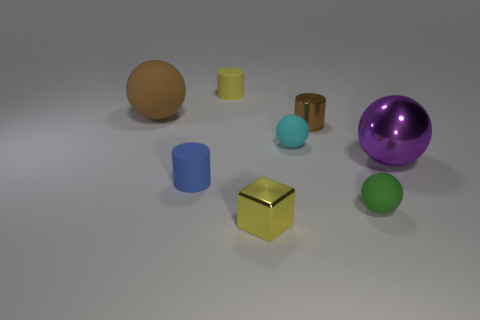Are there any matte things of the same color as the tiny metal cube?
Provide a short and direct response. Yes. There is a object that is the same color as the tiny shiny cylinder; what size is it?
Make the answer very short. Large. There is another object that is the same size as the purple shiny object; what is its color?
Ensure brevity in your answer.  Brown. There is a brown matte thing; does it have the same shape as the big thing to the right of the small cyan thing?
Ensure brevity in your answer.  Yes. What number of things are small things that are behind the green matte sphere or objects that are right of the brown matte sphere?
Your response must be concise. 7. There is a matte object that is the same color as the metal cube; what shape is it?
Offer a terse response. Cylinder. There is a large object on the left side of the tiny yellow metallic cube; what is its shape?
Offer a very short reply. Sphere. There is a shiny thing that is right of the brown shiny thing; does it have the same shape as the yellow shiny thing?
Give a very brief answer. No. What number of things are matte things right of the tiny cube or big purple balls?
Offer a terse response. 3. What is the color of the other tiny object that is the same shape as the green rubber thing?
Give a very brief answer. Cyan. 